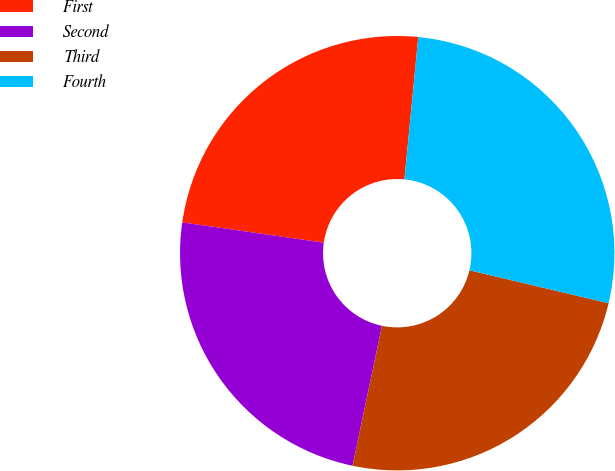Convert chart. <chart><loc_0><loc_0><loc_500><loc_500><pie_chart><fcel>First<fcel>Second<fcel>Third<fcel>Fourth<nl><fcel>24.28%<fcel>23.97%<fcel>24.6%<fcel>27.15%<nl></chart> 